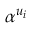<formula> <loc_0><loc_0><loc_500><loc_500>\alpha ^ { u _ { i } }</formula> 